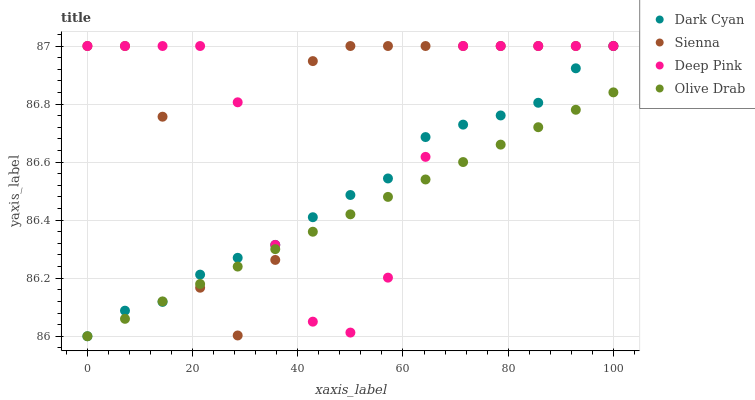Does Olive Drab have the minimum area under the curve?
Answer yes or no. Yes. Does Sienna have the maximum area under the curve?
Answer yes or no. Yes. Does Deep Pink have the minimum area under the curve?
Answer yes or no. No. Does Deep Pink have the maximum area under the curve?
Answer yes or no. No. Is Olive Drab the smoothest?
Answer yes or no. Yes. Is Sienna the roughest?
Answer yes or no. Yes. Is Deep Pink the smoothest?
Answer yes or no. No. Is Deep Pink the roughest?
Answer yes or no. No. Does Dark Cyan have the lowest value?
Answer yes or no. Yes. Does Sienna have the lowest value?
Answer yes or no. No. Does Deep Pink have the highest value?
Answer yes or no. Yes. Does Olive Drab have the highest value?
Answer yes or no. No. Does Olive Drab intersect Dark Cyan?
Answer yes or no. Yes. Is Olive Drab less than Dark Cyan?
Answer yes or no. No. Is Olive Drab greater than Dark Cyan?
Answer yes or no. No. 